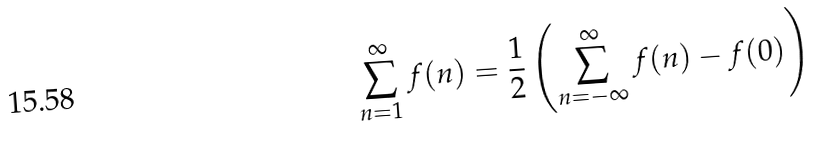<formula> <loc_0><loc_0><loc_500><loc_500>\sum _ { n = 1 } ^ { \infty } f ( n ) = \frac { 1 } { 2 } \left ( \sum _ { n = - \infty } ^ { \infty } f ( n ) - f ( 0 ) \right )</formula> 